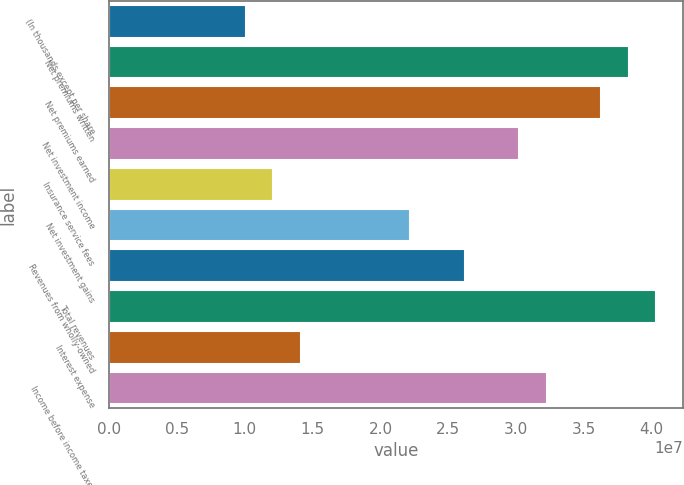Convert chart. <chart><loc_0><loc_0><loc_500><loc_500><bar_chart><fcel>(In thousands except per share<fcel>Net premiums written<fcel>Net premiums earned<fcel>Net investment income<fcel>Insurance service fees<fcel>Net investment gains<fcel>Revenues from wholly-owned<fcel>Total revenues<fcel>Interest expense<fcel>Income before income taxes<nl><fcel>1.00779e+07<fcel>3.82962e+07<fcel>3.62806e+07<fcel>3.02338e+07<fcel>1.20935e+07<fcel>2.21715e+07<fcel>2.62027e+07<fcel>4.03118e+07<fcel>1.41091e+07<fcel>3.22494e+07<nl></chart> 